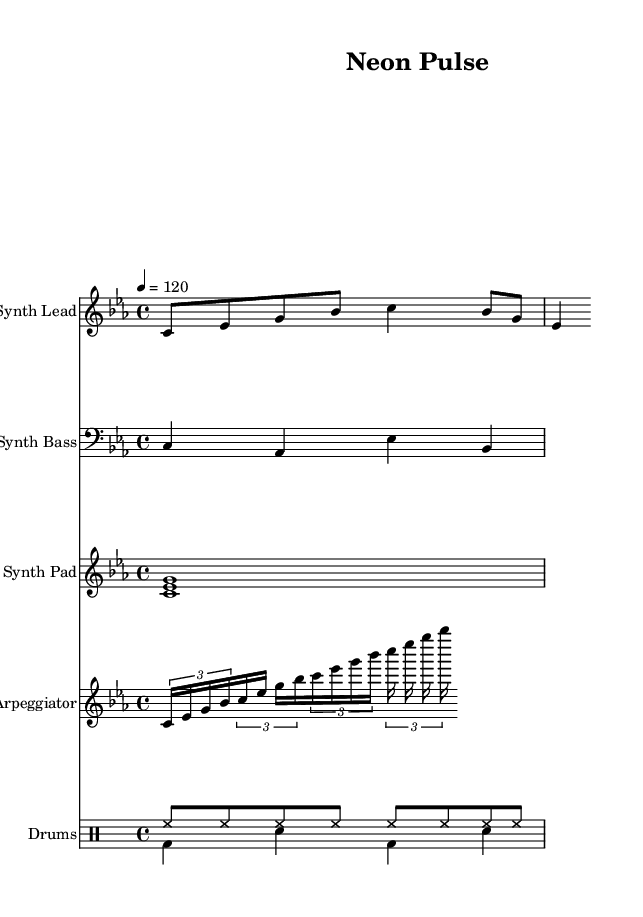What is the key signature of this music? The key signature displayed at the beginning of the score indicates C minor, which has three flats (B flat, E flat, and A flat).
Answer: C minor What is the time signature of this music? The time signature shown on the score is 4/4, which means there are four beats in each measure and the quarter note gets one beat.
Answer: 4/4 What is the tempo marking of this music? The tempo marking indicates 120 beats per minute, which suggests a moderate speed for the performance.
Answer: 120 How many measures are there in the synth lead? By counting the rhythmic groupings and the number of grouped notes in the synth lead staff, there are a total of 8 measures.
Answer: 8 What is the primary instrument used for the arpeggiator? The arpeggiator is written with a relative pitch to the high octave and is typically played on a synthesizer, which is standard in synthwave music.
Answer: Synthesizer What type of drums are used in this piece? The drum patterns indicate the use of hi-hat and bass drum sounds, commonly found in electronic music genres, including synthwave.
Answer: Hi-hat and Bass drum What is the main function of the synth pad in this music? The synth pad provides harmonic support and sustains notes to create a lush texture, characterizing the atmospheric sound found in synthwave tracks.
Answer: Harmonic support 